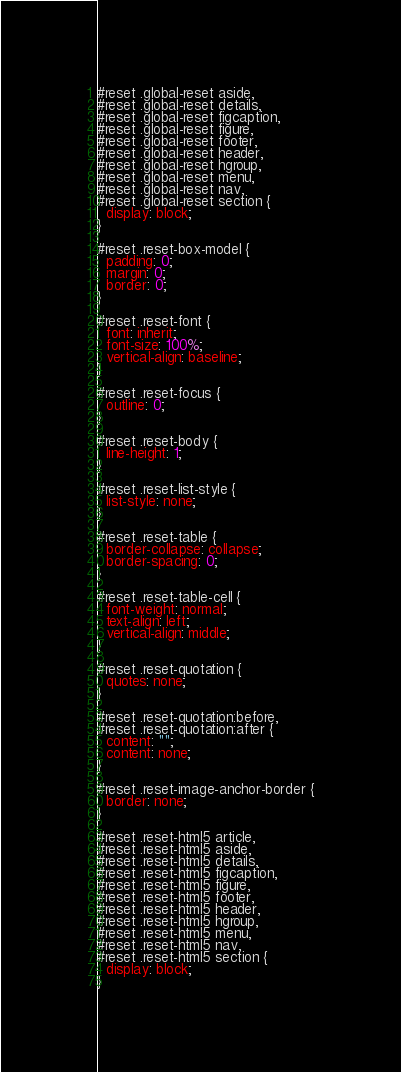<code> <loc_0><loc_0><loc_500><loc_500><_CSS_>#reset .global-reset aside,
#reset .global-reset details,
#reset .global-reset figcaption,
#reset .global-reset figure,
#reset .global-reset footer,
#reset .global-reset header,
#reset .global-reset hgroup,
#reset .global-reset menu,
#reset .global-reset nav,
#reset .global-reset section {
  display: block;
}

#reset .reset-box-model {
  padding: 0;
  margin: 0;
  border: 0;
}

#reset .reset-font {
  font: inherit;
  font-size: 100%;
  vertical-align: baseline;
}

#reset .reset-focus {
  outline: 0;
}

#reset .reset-body {
  line-height: 1;
}

#reset .reset-list-style {
  list-style: none;
}

#reset .reset-table {
  border-collapse: collapse;
  border-spacing: 0;
}

#reset .reset-table-cell {
  font-weight: normal;
  text-align: left;
  vertical-align: middle;
}

#reset .reset-quotation {
  quotes: none;
}

#reset .reset-quotation:before,
#reset .reset-quotation:after {
  content: "";
  content: none;
}

#reset .reset-image-anchor-border {
  border: none;
}

#reset .reset-html5 article,
#reset .reset-html5 aside,
#reset .reset-html5 details,
#reset .reset-html5 figcaption,
#reset .reset-html5 figure,
#reset .reset-html5 footer,
#reset .reset-html5 header,
#reset .reset-html5 hgroup,
#reset .reset-html5 menu,
#reset .reset-html5 nav,
#reset .reset-html5 section {
  display: block;
}</code> 